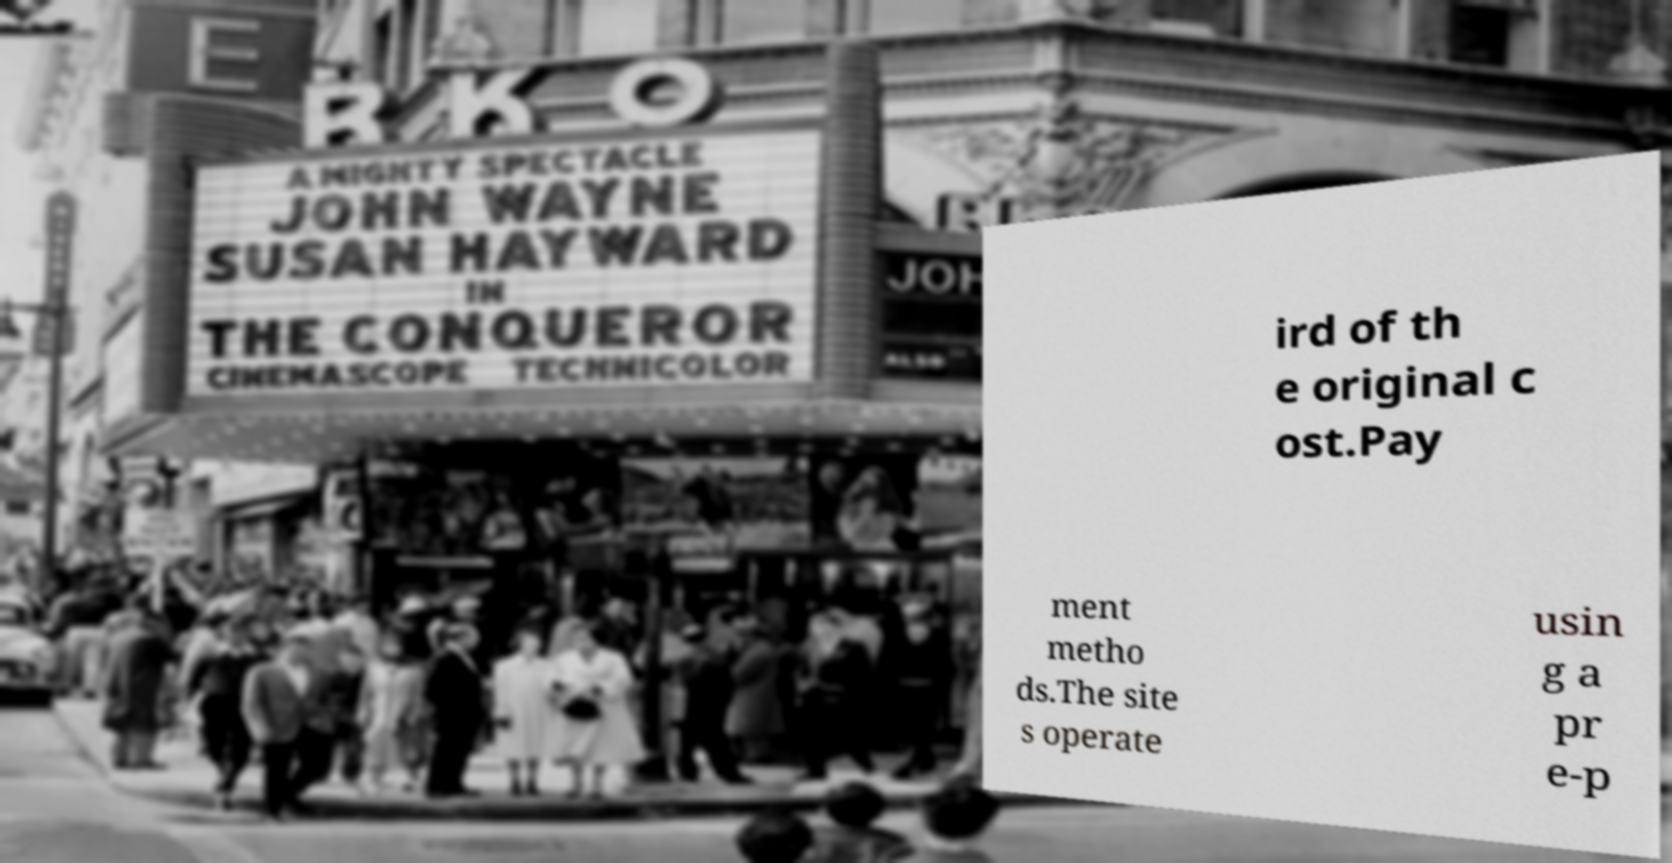Could you extract and type out the text from this image? ird of th e original c ost.Pay ment metho ds.The site s operate usin g a pr e-p 